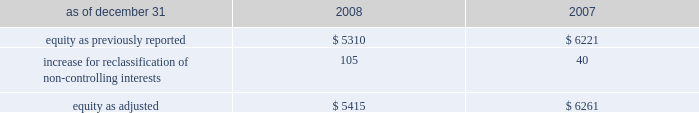The company recognizes the effect of income tax positions only if sustaining those positions is more likely than not .
Changes in recognition or measurement are reflected in the period in which a change in judgment occurs .
The company records penalties and interest related to unrecognized tax benefits in income taxes in the company 2019s consolidated statements of income .
Changes in accounting principles business combinations and noncontrolling interests on january 1 , 2009 , the company adopted revised principles related to business combinations and noncontrolling interests .
The revised principle on business combinations applies to all transactions or other events in which an entity obtains control over one or more businesses .
It requires an acquirer to recognize the assets acquired , the liabilities assumed , and any noncontrolling interest in the acquiree at the acquisition date , measured at their fair values as of that date .
Business combinations achieved in stages require recognition of the identifiable assets and liabilities , as well as the noncontrolling interest in the acquiree , at the full amounts of their fair values when control is obtained .
This revision also changes the requirements for recognizing assets acquired and liabilities assumed arising from contingencies , and requires direct acquisition costs to be expensed .
In addition , it provides certain changes to income tax accounting for business combinations which apply to both new and previously existing business combinations .
In april 2009 , additional guidance was issued which revised certain business combination guidance related to accounting for contingent liabilities assumed in a business combination .
The company has adopted this guidance in conjunction with the adoption of the revised principles related to business combinations .
The adoption of the revised principles related to business combinations has not had a material impact on the consolidated financial statements .
The revised principle related to noncontrolling interests establishes accounting and reporting standards for the noncontrolling interests in a subsidiary and for the deconsolidation of a subsidiary .
The revised principle clarifies that a noncontrolling interest in a subsidiary is an ownership interest in the consolidated entity that should be reported as a separate component of equity in the consolidated statements of financial position .
The revised principle requires retrospective adjustments , for all periods presented , of stockholders 2019 equity and net income for noncontrolling interests .
In addition to these financial reporting changes , the revised principle provides for significant changes in accounting related to changes in ownership of noncontrolling interests .
Changes in aon 2019s controlling financial interests in consolidated subsidiaries that do not result in a loss of control are accounted for as equity transactions similar to treasury stock transactions .
If a change in ownership of a consolidated subsidiary results in a loss of control and deconsolidation , any retained ownership interests are remeasured at fair value with the gain or loss reported in net income .
In previous periods , noncontrolling interests for operating subsidiaries were reported in other general expenses in the consolidated statements of income .
Prior period amounts have been restated to conform to the current year 2019s presentation .
The principal effect on the prior years 2019 balance sheets related to the adoption of the new guidance related to noncontrolling interests is summarized as follows ( in millions ) : .
The revised principle also requires that net income be adjusted to include the net income attributable to the noncontrolling interests and a new separate caption for net income attributable to aon stockholders be presented in the consolidated statements of income .
The adoption of this new guidance increased net income by $ 16 million and $ 13 million for 2008 and 2007 , respectively .
Net .
What is the impact of the reclassification of non-controlling interests in equity? 
Rationale: it is the increase for reclassification of non-controlling interests divided by the original equity to calculate its percentual impact .
Computations: (105 / 5310)
Answer: 0.01977. 